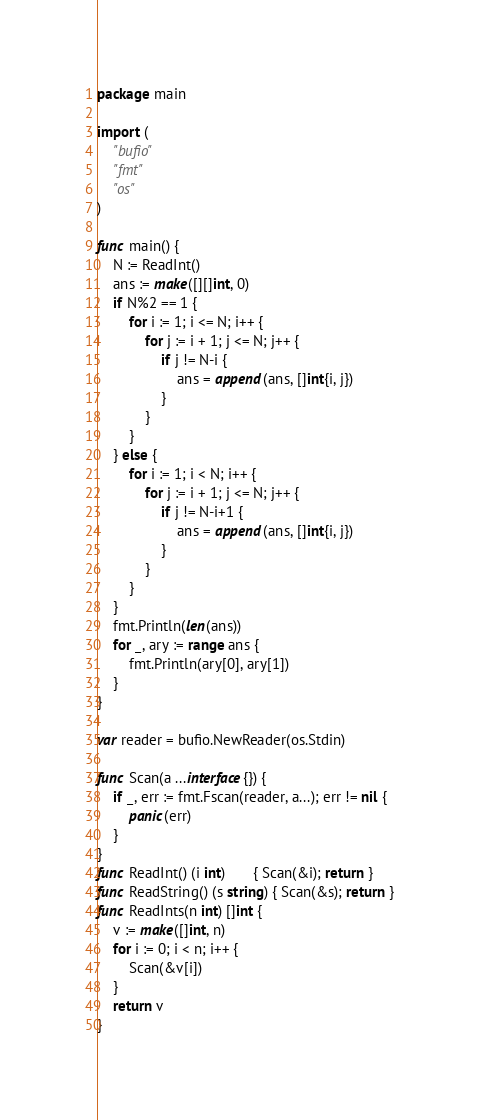<code> <loc_0><loc_0><loc_500><loc_500><_Go_>package main

import (
	"bufio"
	"fmt"
	"os"
)

func main() {
	N := ReadInt()
	ans := make([][]int, 0)
	if N%2 == 1 {
		for i := 1; i <= N; i++ {
			for j := i + 1; j <= N; j++ {
				if j != N-i {
					ans = append(ans, []int{i, j})
				}
			}
		}
	} else {
		for i := 1; i < N; i++ {
			for j := i + 1; j <= N; j++ {
				if j != N-i+1 {
					ans = append(ans, []int{i, j})
				}
			}
		}
	}
	fmt.Println(len(ans))
	for _, ary := range ans {
		fmt.Println(ary[0], ary[1])
	}
}

var reader = bufio.NewReader(os.Stdin)

func Scan(a ...interface{}) {
	if _, err := fmt.Fscan(reader, a...); err != nil {
		panic(err)
	}
}
func ReadInt() (i int)       { Scan(&i); return }
func ReadString() (s string) { Scan(&s); return }
func ReadInts(n int) []int {
	v := make([]int, n)
	for i := 0; i < n; i++ {
		Scan(&v[i])
	}
	return v
}
</code> 